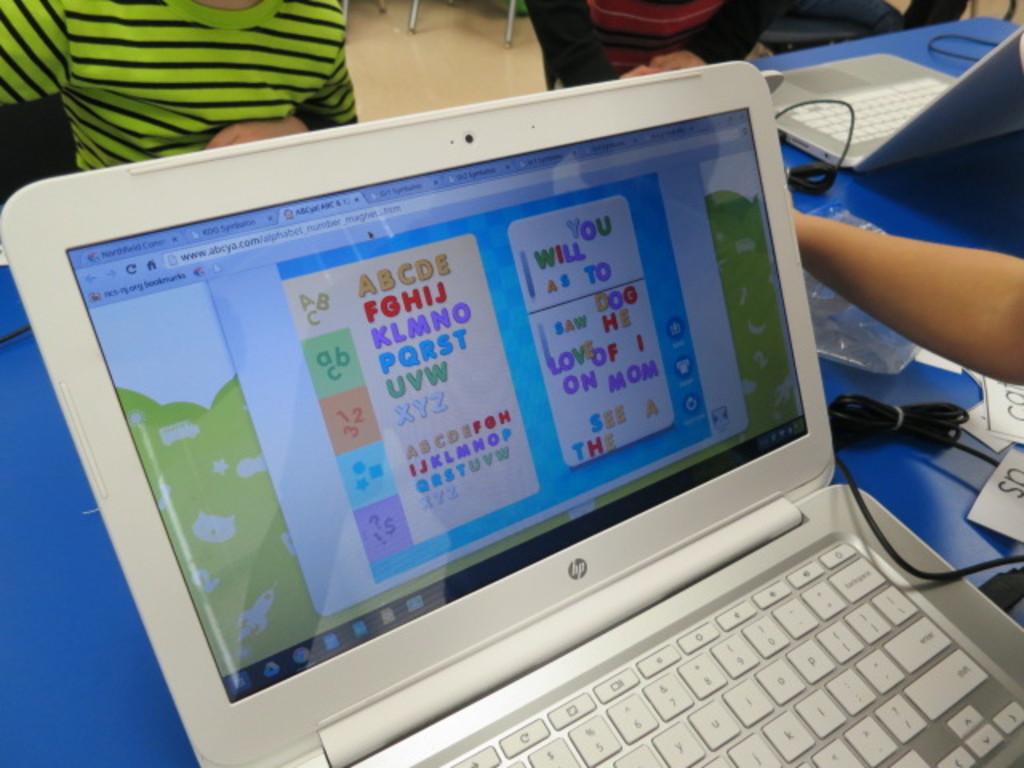What website is being used?
Provide a succinct answer. Abcya.com. What letters are in red on the second line?
Give a very brief answer. Fghij. 